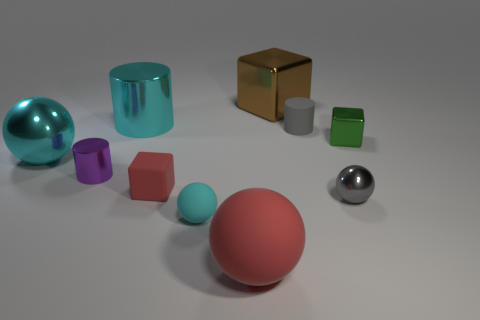Is the color of the tiny rubber cylinder the same as the tiny metal sphere?
Ensure brevity in your answer.  Yes. The small cylinder that is on the left side of the small block to the left of the small cylinder behind the tiny green metal thing is made of what material?
Provide a succinct answer. Metal. Are there more tiny purple metal cylinders that are behind the purple metallic thing than cyan spheres that are behind the small gray ball?
Provide a short and direct response. No. How many cylinders are tiny objects or large things?
Offer a very short reply. 3. There is a small cylinder in front of the gray object behind the tiny metallic block; how many metal spheres are behind it?
Offer a terse response. 1. There is a tiny thing that is the same color as the tiny rubber cylinder; what is it made of?
Keep it short and to the point. Metal. Is the number of big objects greater than the number of small green objects?
Make the answer very short. Yes. Do the purple metal object and the gray matte thing have the same size?
Ensure brevity in your answer.  Yes. What number of things are either metal objects or large brown cubes?
Offer a terse response. 6. There is a big object in front of the shiny ball that is on the right side of the tiny cylinder that is right of the tiny red block; what is its shape?
Provide a short and direct response. Sphere. 